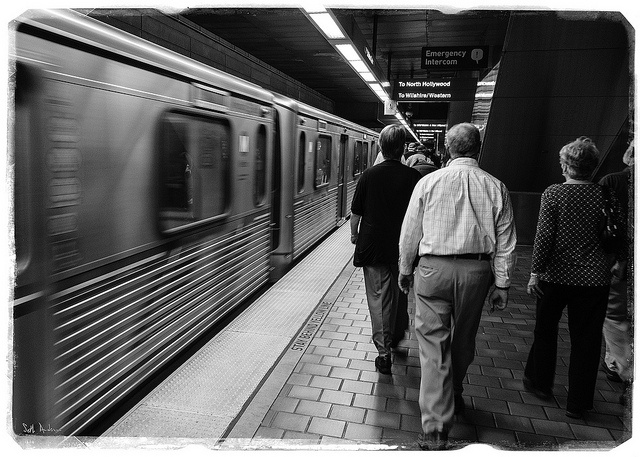Describe the objects in this image and their specific colors. I can see train in white, black, gray, darkgray, and lightgray tones, people in white, black, gray, darkgray, and lightgray tones, people in white, black, gray, darkgray, and lightgray tones, people in white, black, gray, darkgray, and lightgray tones, and people in black, gray, and white tones in this image. 